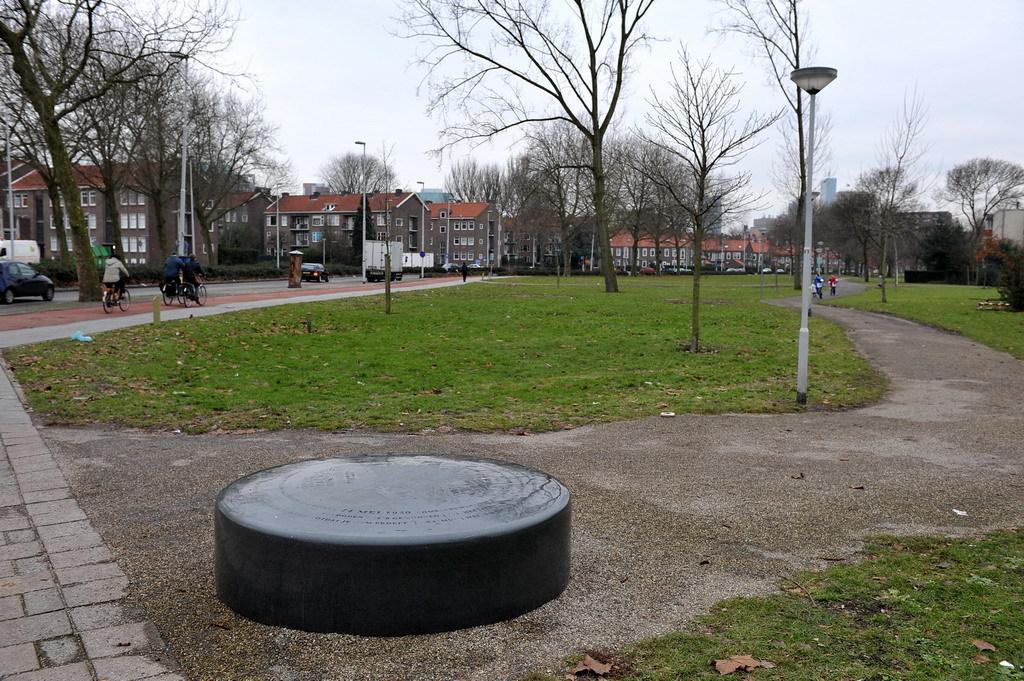Please provide a concise description of this image. In the center of the image we can see buildings, electric light poles, some persons riding bicycle, cars, road, grass, ground, trees are present. At the top of the image sky is there. At the bottom of the image ground and stone are there. 